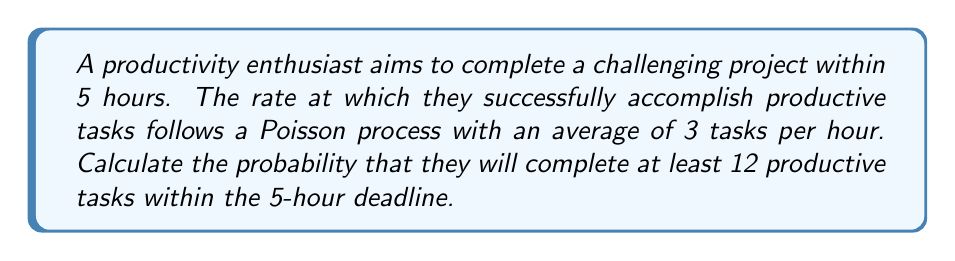Can you answer this question? Let's approach this step-by-step using the Poisson process:

1) In a Poisson process, the number of events in a fixed interval follows a Poisson distribution.

2) Given:
   - Rate (λ) = 3 tasks per hour
   - Time interval (t) = 5 hours
   - We want at least 12 tasks completed

3) The average number of tasks in 5 hours:
   $$\mu = \lambda t = 3 \times 5 = 15$$

4) We need to find P(X ≥ 12), where X is the number of tasks completed.

5) This is equivalent to 1 - P(X < 12) or 1 - P(X ≤ 11)

6) The probability of X ≤ k in a Poisson distribution is given by:

   $$P(X \leq k) = e^{-\mu} \sum_{i=0}^k \frac{\mu^i}{i!}$$

7) Therefore, we need to calculate:

   $$1 - e^{-15} \sum_{i=0}^{11} \frac{15^i}{i!}$$

8) This can be computed using statistical software or a calculator with Poisson distribution functions.

9) The result of this calculation is approximately 0.8412.
Answer: $0.8412$ or $84.12\%$ 